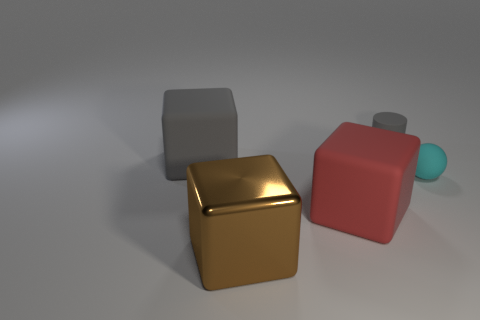Is there anything else that has the same material as the large brown cube?
Offer a terse response. No. Is the size of the rubber cube that is behind the tiny cyan matte thing the same as the gray thing that is behind the big gray rubber object?
Offer a terse response. No. Is the number of tiny rubber spheres behind the big red rubber thing greater than the number of cylinders in front of the big gray cube?
Your response must be concise. Yes. How many other big matte things have the same shape as the brown thing?
Your answer should be compact. 2. There is a brown block that is the same size as the red thing; what material is it?
Give a very brief answer. Metal. Is there a gray thing that has the same material as the cyan object?
Offer a terse response. Yes. Are there fewer gray cylinders that are in front of the small gray object than purple rubber blocks?
Provide a short and direct response. No. What is the material of the large object in front of the big cube to the right of the large brown cube?
Your answer should be very brief. Metal. There is a object that is on the left side of the red matte cube and behind the big brown cube; what shape is it?
Give a very brief answer. Cube. How many other things are there of the same color as the shiny thing?
Provide a succinct answer. 0. 